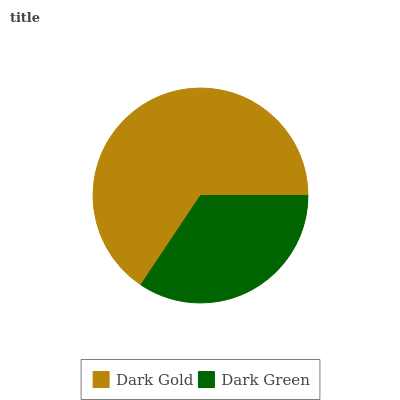Is Dark Green the minimum?
Answer yes or no. Yes. Is Dark Gold the maximum?
Answer yes or no. Yes. Is Dark Green the maximum?
Answer yes or no. No. Is Dark Gold greater than Dark Green?
Answer yes or no. Yes. Is Dark Green less than Dark Gold?
Answer yes or no. Yes. Is Dark Green greater than Dark Gold?
Answer yes or no. No. Is Dark Gold less than Dark Green?
Answer yes or no. No. Is Dark Gold the high median?
Answer yes or no. Yes. Is Dark Green the low median?
Answer yes or no. Yes. Is Dark Green the high median?
Answer yes or no. No. Is Dark Gold the low median?
Answer yes or no. No. 